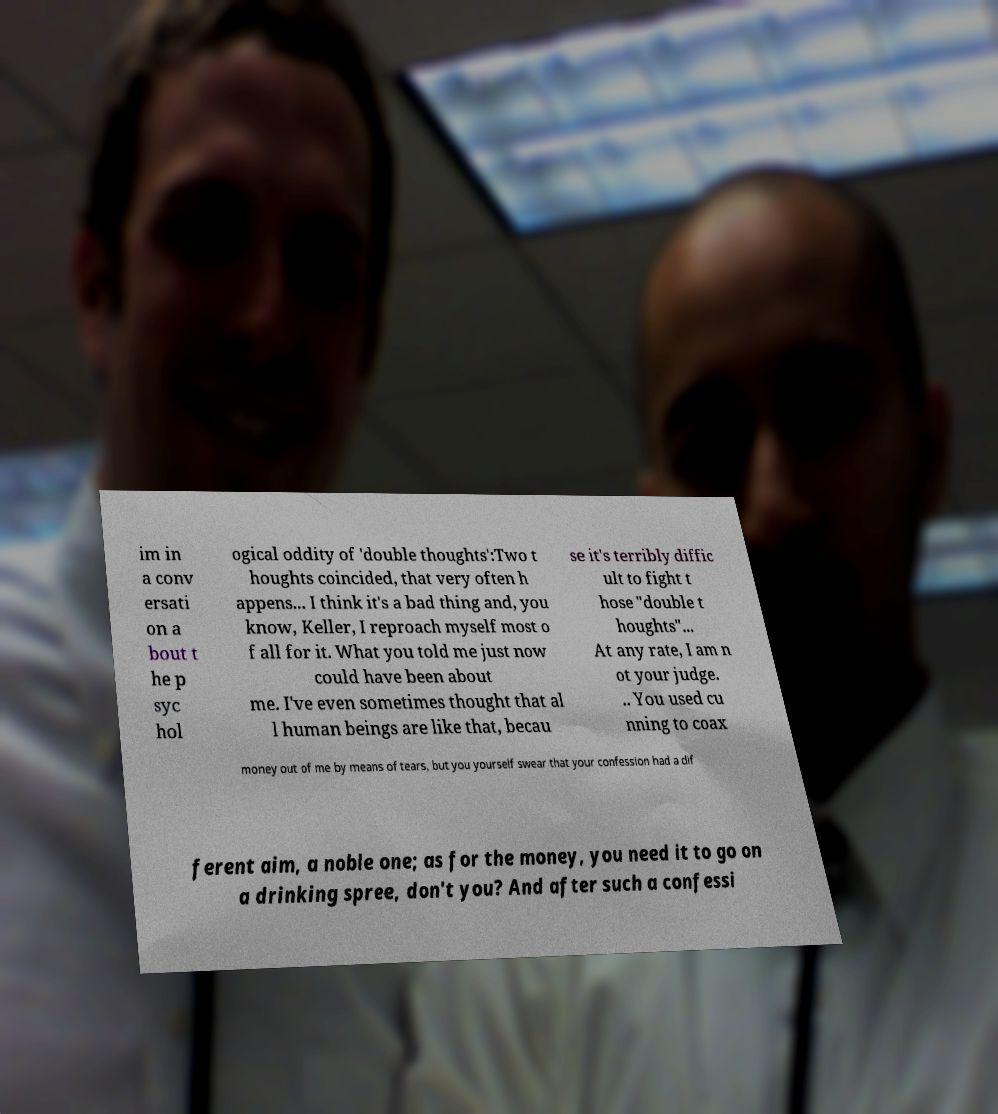Please read and relay the text visible in this image. What does it say? im in a conv ersati on a bout t he p syc hol ogical oddity of 'double thoughts':Two t houghts coincided, that very often h appens... I think it's a bad thing and, you know, Keller, I reproach myself most o f all for it. What you told me just now could have been about me. I've even sometimes thought that al l human beings are like that, becau se it's terribly diffic ult to fight t hose "double t houghts"... At any rate, I am n ot your judge. .. You used cu nning to coax money out of me by means of tears, but you yourself swear that your confession had a dif ferent aim, a noble one; as for the money, you need it to go on a drinking spree, don't you? And after such a confessi 